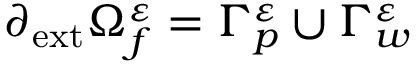<formula> <loc_0><loc_0><loc_500><loc_500>\partial _ { e x t } \Omega _ { f } ^ { \varepsilon } = \Gamma _ { p } ^ { \varepsilon } \cup \Gamma _ { w } ^ { \varepsilon }</formula> 